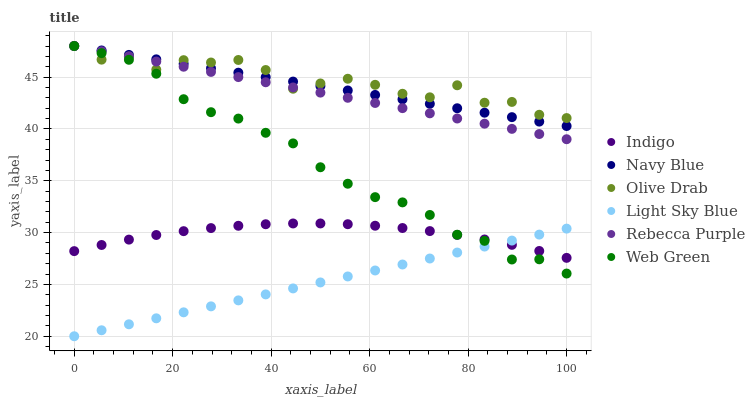Does Light Sky Blue have the minimum area under the curve?
Answer yes or no. Yes. Does Olive Drab have the maximum area under the curve?
Answer yes or no. Yes. Does Navy Blue have the minimum area under the curve?
Answer yes or no. No. Does Navy Blue have the maximum area under the curve?
Answer yes or no. No. Is Navy Blue the smoothest?
Answer yes or no. Yes. Is Olive Drab the roughest?
Answer yes or no. Yes. Is Web Green the smoothest?
Answer yes or no. No. Is Web Green the roughest?
Answer yes or no. No. Does Light Sky Blue have the lowest value?
Answer yes or no. Yes. Does Navy Blue have the lowest value?
Answer yes or no. No. Does Olive Drab have the highest value?
Answer yes or no. Yes. Does Light Sky Blue have the highest value?
Answer yes or no. No. Is Indigo less than Olive Drab?
Answer yes or no. Yes. Is Rebecca Purple greater than Light Sky Blue?
Answer yes or no. Yes. Does Web Green intersect Navy Blue?
Answer yes or no. Yes. Is Web Green less than Navy Blue?
Answer yes or no. No. Is Web Green greater than Navy Blue?
Answer yes or no. No. Does Indigo intersect Olive Drab?
Answer yes or no. No. 